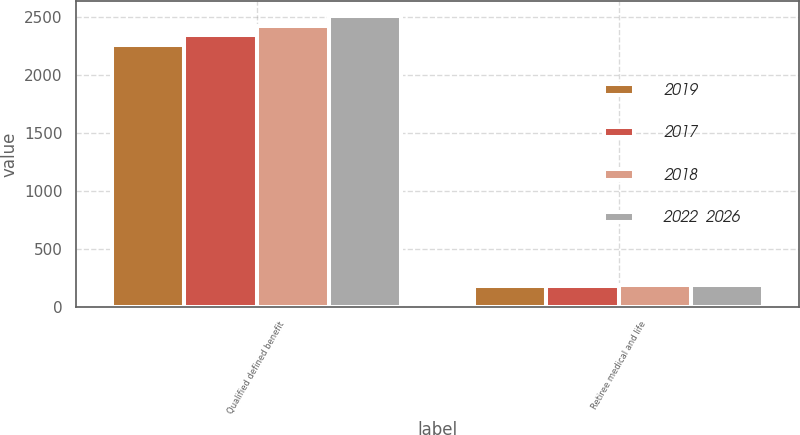<chart> <loc_0><loc_0><loc_500><loc_500><stacked_bar_chart><ecel><fcel>Qualified defined benefit<fcel>Retiree medical and life<nl><fcel>2019<fcel>2260<fcel>180<nl><fcel>2017<fcel>2340<fcel>180<nl><fcel>2018<fcel>2420<fcel>190<nl><fcel>2022  2026<fcel>2510<fcel>190<nl></chart> 